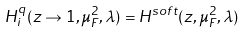Convert formula to latex. <formula><loc_0><loc_0><loc_500><loc_500>H ^ { q } _ { i } ( z \to 1 , \mu _ { F } ^ { 2 } , \lambda ) = H ^ { s o f t } ( z , \mu _ { F } ^ { 2 } , \lambda )</formula> 